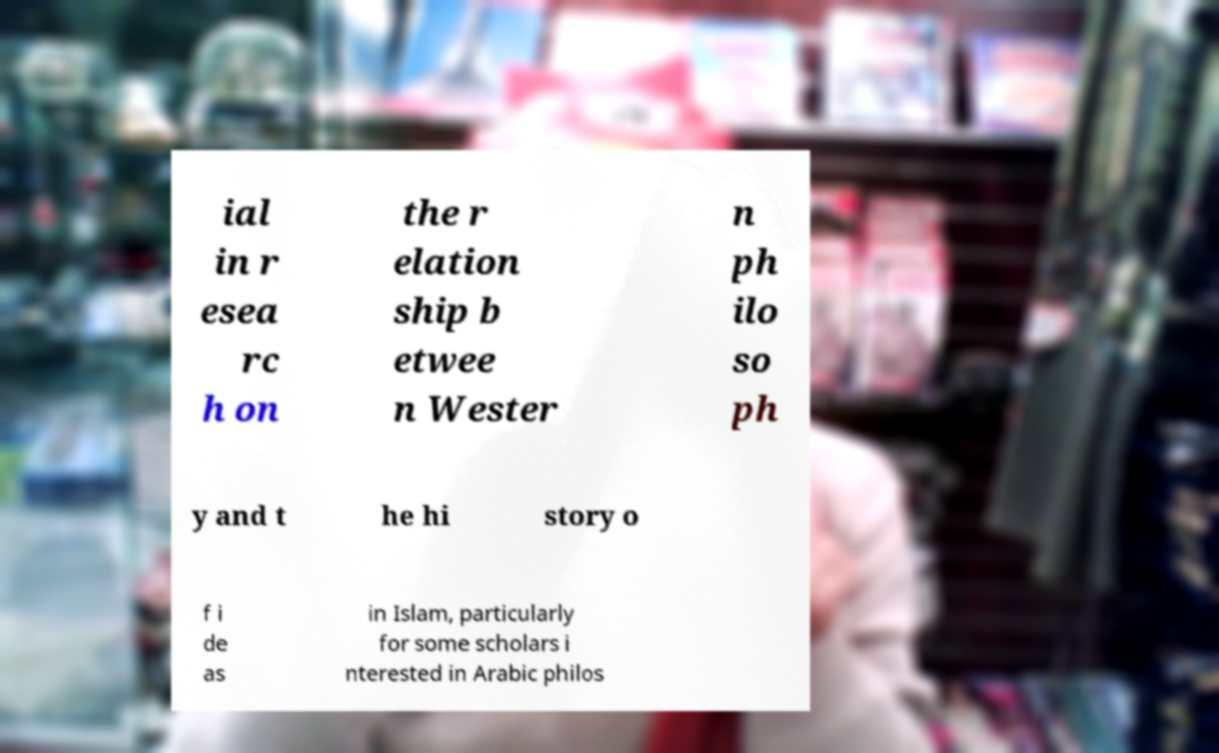Can you accurately transcribe the text from the provided image for me? ial in r esea rc h on the r elation ship b etwee n Wester n ph ilo so ph y and t he hi story o f i de as in Islam, particularly for some scholars i nterested in Arabic philos 